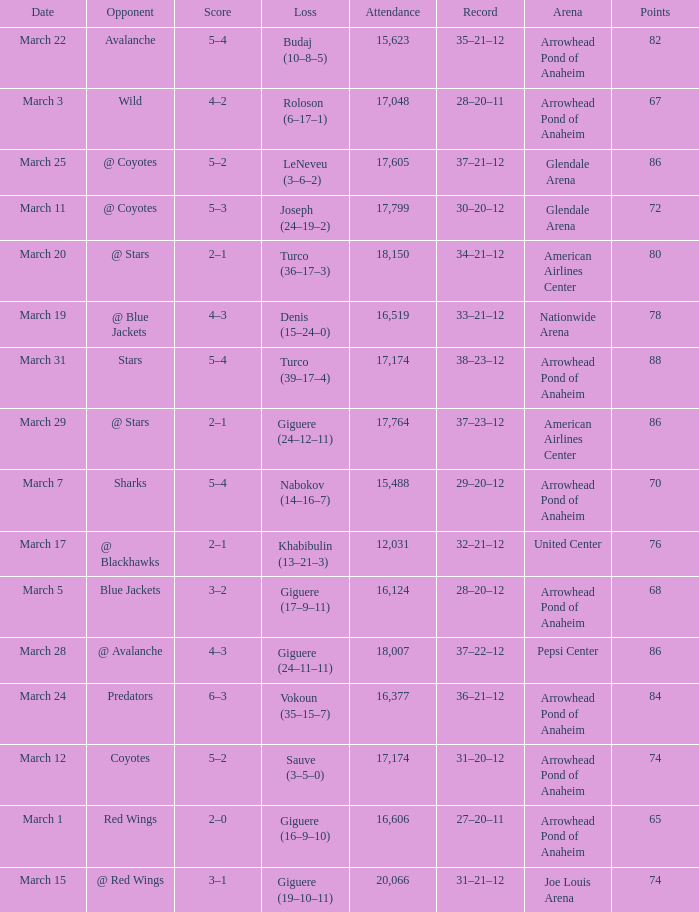What is the Loss of the game at Nationwide Arena with a Score of 4–3? Denis (15–24–0). 